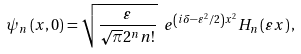<formula> <loc_0><loc_0><loc_500><loc_500>\psi _ { n } \left ( x , 0 \right ) = \sqrt { \frac { \varepsilon } { \sqrt { \pi } 2 ^ { n } n ! } } \ e ^ { \left ( i \delta - \varepsilon ^ { 2 } / 2 \right ) x ^ { 2 } } H _ { n } \left ( \varepsilon x \right ) ,</formula> 